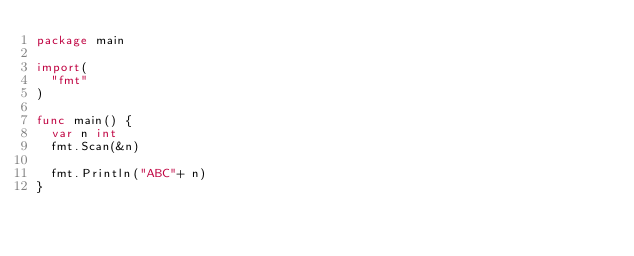<code> <loc_0><loc_0><loc_500><loc_500><_Go_>package main

import(
  "fmt"
)

func main() {
  var n int
  fmt.Scan(&n)
  
  fmt.Println("ABC"+ n)
}</code> 